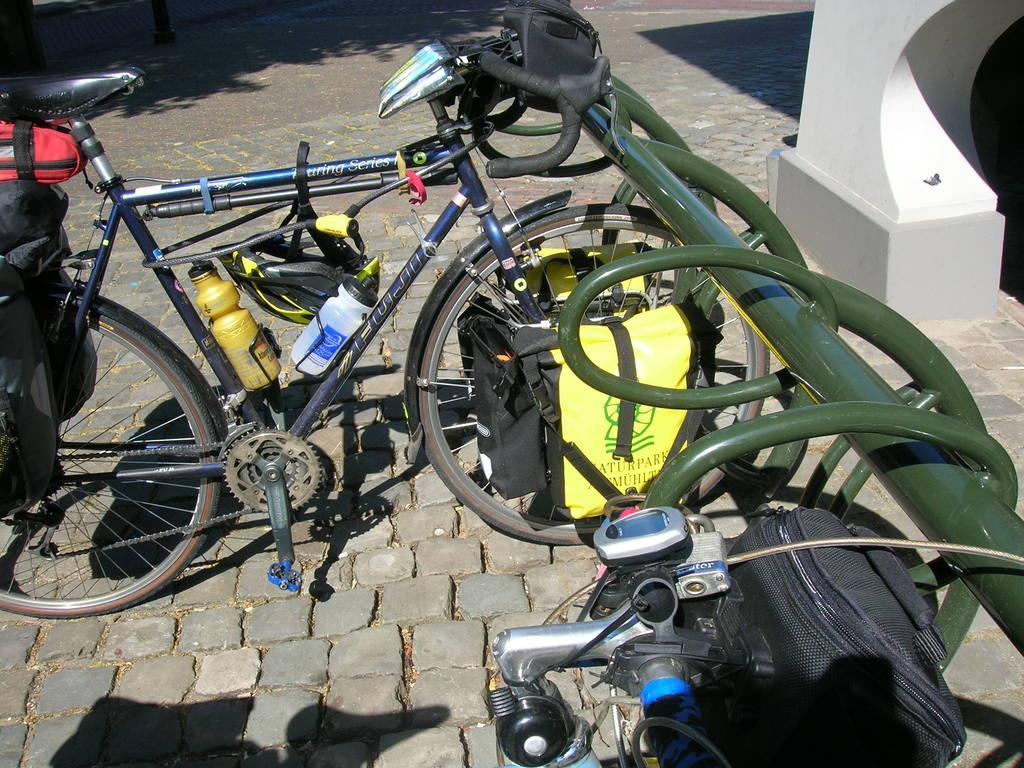Could you give a brief overview of what you see in this image? In this image there is a bicycle parked on the path. On the bicycle there is a helmet, bottles and other objects, beside the bicycle there is a metal structure. On the right side of the image there is a wall. 